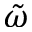<formula> <loc_0><loc_0><loc_500><loc_500>\tilde { \omega }</formula> 